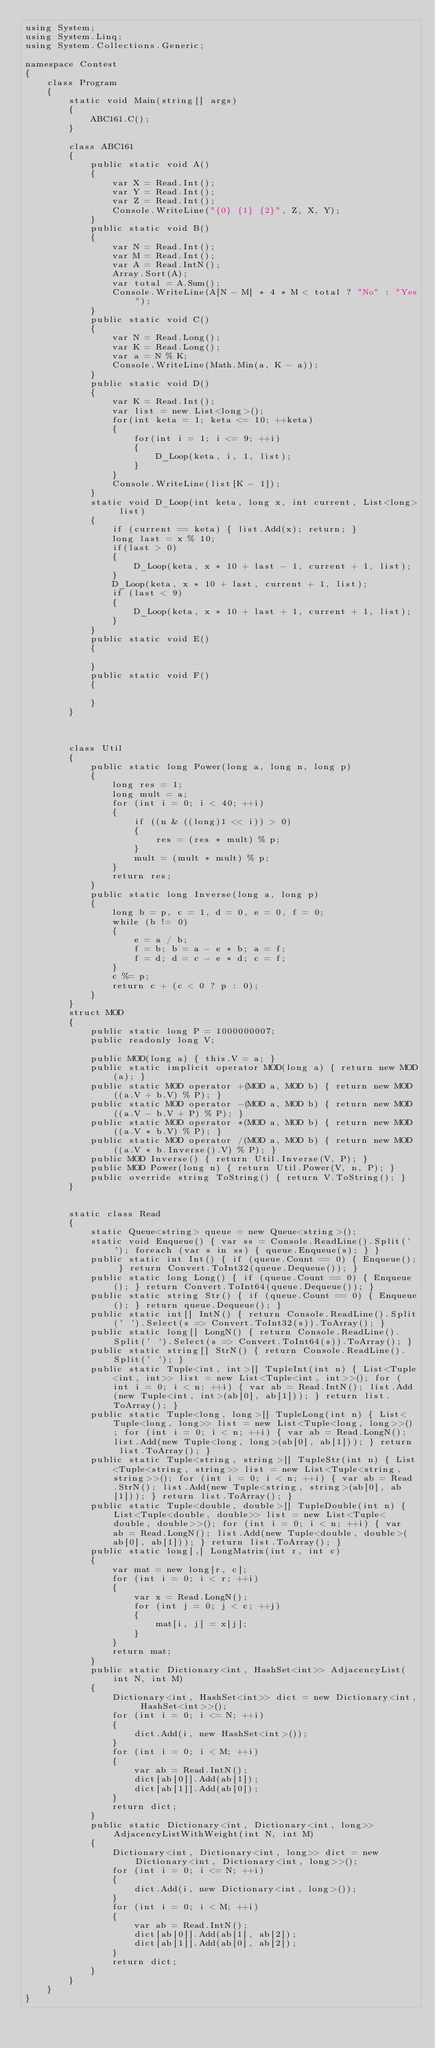Convert code to text. <code><loc_0><loc_0><loc_500><loc_500><_C#_>using System;
using System.Linq;
using System.Collections.Generic;

namespace Contest
{
    class Program
    {
        static void Main(string[] args)
        {
            ABC161.C();
        }

        class ABC161
        {
            public static void A()
            {
                var X = Read.Int();
                var Y = Read.Int();
                var Z = Read.Int();
                Console.WriteLine("{0} {1} {2}", Z, X, Y);
            }
            public static void B()
            {
                var N = Read.Int();
                var M = Read.Int();
                var A = Read.IntN();
                Array.Sort(A);
                var total = A.Sum();
                Console.WriteLine(A[N - M] * 4 * M < total ? "No" : "Yes");
            }
            public static void C()
            {
                var N = Read.Long();
                var K = Read.Long();
                var a = N % K;
                Console.WriteLine(Math.Min(a, K - a));
            }
            public static void D()
            {
                var K = Read.Int();
                var list = new List<long>();
                for(int keta = 1; keta <= 10; ++keta)
                {
                    for(int i = 1; i <= 9; ++i)
                    {
                        D_Loop(keta, i, 1, list);
                    }
                }
                Console.WriteLine(list[K - 1]);
            }
            static void D_Loop(int keta, long x, int current, List<long> list)
            {
                if (current == keta) { list.Add(x); return; }
                long last = x % 10;
                if(last > 0)
                {
                    D_Loop(keta, x * 10 + last - 1, current + 1, list);
                }
                D_Loop(keta, x * 10 + last, current + 1, list);
                if (last < 9)
                {
                    D_Loop(keta, x * 10 + last + 1, current + 1, list);
                }
            }
            public static void E()
            {

            }
            public static void F()
            {

            }
        }



        class Util
        {
            public static long Power(long a, long n, long p)
            {
                long res = 1;
                long mult = a;
                for (int i = 0; i < 40; ++i)
                {
                    if ((n & ((long)1 << i)) > 0)
                    {
                        res = (res * mult) % p;
                    }
                    mult = (mult * mult) % p;
                }
                return res;
            }
            public static long Inverse(long a, long p)
            {
                long b = p, c = 1, d = 0, e = 0, f = 0;
                while (b != 0)
                {
                    e = a / b;
                    f = b; b = a - e * b; a = f;
                    f = d; d = c - e * d; c = f;
                }
                c %= p;
                return c + (c < 0 ? p : 0);
            }
        }
        struct MOD
        {
            public static long P = 1000000007;
            public readonly long V;

            public MOD(long a) { this.V = a; }
            public static implicit operator MOD(long a) { return new MOD(a); }
            public static MOD operator +(MOD a, MOD b) { return new MOD((a.V + b.V) % P); }
            public static MOD operator -(MOD a, MOD b) { return new MOD((a.V - b.V + P) % P); }
            public static MOD operator *(MOD a, MOD b) { return new MOD((a.V * b.V) % P); }
            public static MOD operator /(MOD a, MOD b) { return new MOD((a.V * b.Inverse().V) % P); }
            public MOD Inverse() { return Util.Inverse(V, P); }
            public MOD Power(long n) { return Util.Power(V, n, P); }
            public override string ToString() { return V.ToString(); }
        }


        static class Read
        {
            static Queue<string> queue = new Queue<string>();
            static void Enqueue() { var ss = Console.ReadLine().Split(' '); foreach (var s in ss) { queue.Enqueue(s); } }
            public static int Int() { if (queue.Count == 0) { Enqueue(); } return Convert.ToInt32(queue.Dequeue()); }
            public static long Long() { if (queue.Count == 0) { Enqueue(); } return Convert.ToInt64(queue.Dequeue()); }
            public static string Str() { if (queue.Count == 0) { Enqueue(); } return queue.Dequeue(); }
            public static int[] IntN() { return Console.ReadLine().Split(' ').Select(s => Convert.ToInt32(s)).ToArray(); }
            public static long[] LongN() { return Console.ReadLine().Split(' ').Select(s => Convert.ToInt64(s)).ToArray(); }
            public static string[] StrN() { return Console.ReadLine().Split(' '); }
            public static Tuple<int, int>[] TupleInt(int n) { List<Tuple<int, int>> list = new List<Tuple<int, int>>(); for (int i = 0; i < n; ++i) { var ab = Read.IntN(); list.Add(new Tuple<int, int>(ab[0], ab[1])); } return list.ToArray(); }
            public static Tuple<long, long>[] TupleLong(int n) { List<Tuple<long, long>> list = new List<Tuple<long, long>>(); for (int i = 0; i < n; ++i) { var ab = Read.LongN(); list.Add(new Tuple<long, long>(ab[0], ab[1])); } return list.ToArray(); }
            public static Tuple<string, string>[] TupleStr(int n) { List<Tuple<string, string>> list = new List<Tuple<string, string>>(); for (int i = 0; i < n; ++i) { var ab = Read.StrN(); list.Add(new Tuple<string, string>(ab[0], ab[1])); } return list.ToArray(); }
            public static Tuple<double, double>[] TupleDouble(int n) { List<Tuple<double, double>> list = new List<Tuple<double, double>>(); for (int i = 0; i < n; ++i) { var ab = Read.LongN(); list.Add(new Tuple<double, double>(ab[0], ab[1])); } return list.ToArray(); }
            public static long[,] LongMatrix(int r, int c)
            {
                var mat = new long[r, c];
                for (int i = 0; i < r; ++i)
                {
                    var x = Read.LongN();
                    for (int j = 0; j < c; ++j)
                    {
                        mat[i, j] = x[j];
                    }
                }
                return mat;
            }
            public static Dictionary<int, HashSet<int>> AdjacencyList(int N, int M)
            {
                Dictionary<int, HashSet<int>> dict = new Dictionary<int, HashSet<int>>();
                for (int i = 0; i <= N; ++i)
                {
                    dict.Add(i, new HashSet<int>());
                }
                for (int i = 0; i < M; ++i)
                {
                    var ab = Read.IntN();
                    dict[ab[0]].Add(ab[1]);
                    dict[ab[1]].Add(ab[0]);
                }
                return dict;
            }
            public static Dictionary<int, Dictionary<int, long>> AdjacencyListWithWeight(int N, int M)
            {
                Dictionary<int, Dictionary<int, long>> dict = new Dictionary<int, Dictionary<int, long>>();
                for (int i = 0; i <= N; ++i)
                {
                    dict.Add(i, new Dictionary<int, long>());
                }
                for (int i = 0; i < M; ++i)
                {
                    var ab = Read.IntN();
                    dict[ab[0]].Add(ab[1], ab[2]);
                    dict[ab[1]].Add(ab[0], ab[2]);
                }
                return dict;
            }
        }
    }
}
</code> 